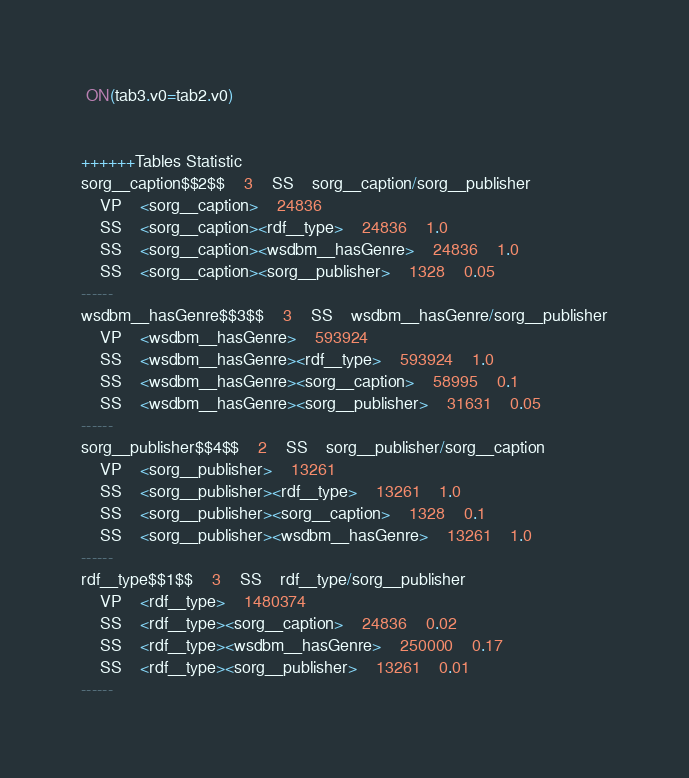Convert code to text. <code><loc_0><loc_0><loc_500><loc_500><_SQL_> ON(tab3.v0=tab2.v0)


++++++Tables Statistic
sorg__caption$$2$$	3	SS	sorg__caption/sorg__publisher
	VP	<sorg__caption>	24836
	SS	<sorg__caption><rdf__type>	24836	1.0
	SS	<sorg__caption><wsdbm__hasGenre>	24836	1.0
	SS	<sorg__caption><sorg__publisher>	1328	0.05
------
wsdbm__hasGenre$$3$$	3	SS	wsdbm__hasGenre/sorg__publisher
	VP	<wsdbm__hasGenre>	593924
	SS	<wsdbm__hasGenre><rdf__type>	593924	1.0
	SS	<wsdbm__hasGenre><sorg__caption>	58995	0.1
	SS	<wsdbm__hasGenre><sorg__publisher>	31631	0.05
------
sorg__publisher$$4$$	2	SS	sorg__publisher/sorg__caption
	VP	<sorg__publisher>	13261
	SS	<sorg__publisher><rdf__type>	13261	1.0
	SS	<sorg__publisher><sorg__caption>	1328	0.1
	SS	<sorg__publisher><wsdbm__hasGenre>	13261	1.0
------
rdf__type$$1$$	3	SS	rdf__type/sorg__publisher
	VP	<rdf__type>	1480374
	SS	<rdf__type><sorg__caption>	24836	0.02
	SS	<rdf__type><wsdbm__hasGenre>	250000	0.17
	SS	<rdf__type><sorg__publisher>	13261	0.01
------
</code> 